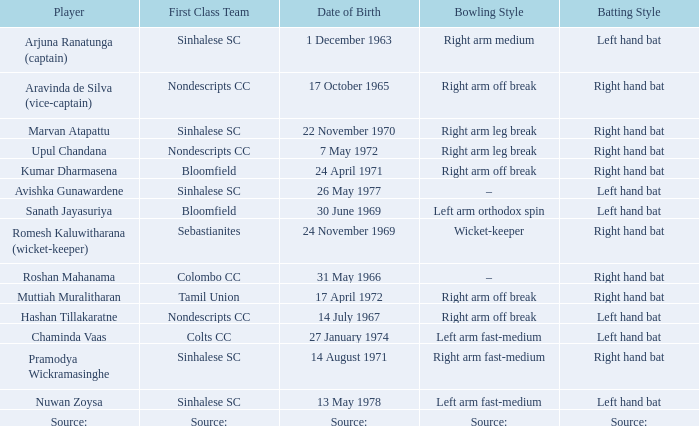When was avishka gunawardene born? 26 May 1977. 